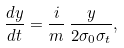Convert formula to latex. <formula><loc_0><loc_0><loc_500><loc_500>\frac { d y } { d t } = \frac { i } { m } \, \frac { y } { 2 \sigma _ { 0 } \sigma _ { t } } ,</formula> 